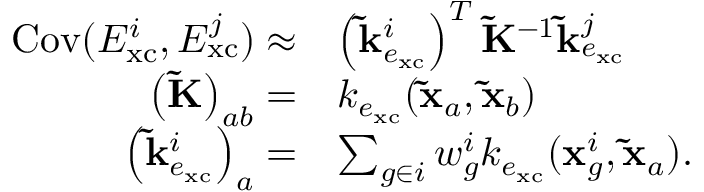<formula> <loc_0><loc_0><loc_500><loc_500>\begin{array} { r l } { C o v ( E _ { x c } ^ { i } , E _ { x c } ^ { j } ) \approx } & { \left ( \tilde { k } _ { e _ { x c } } ^ { i } \right ) ^ { T } \widetilde { K } ^ { - 1 } \tilde { k } _ { e _ { x c } } ^ { j } } \\ { \left ( \widetilde { K } \right ) _ { a b } = } & { k _ { e _ { x c } } ( \tilde { x } _ { a } , \tilde { x } _ { b } ) } \\ { \left ( \tilde { k } _ { e _ { x c } } ^ { i } \right ) _ { a } = } & { \sum _ { g \in i } w _ { g } ^ { i } k _ { e _ { x c } } ( x _ { g } ^ { i } , \tilde { x } _ { a } ) . } \end{array}</formula> 